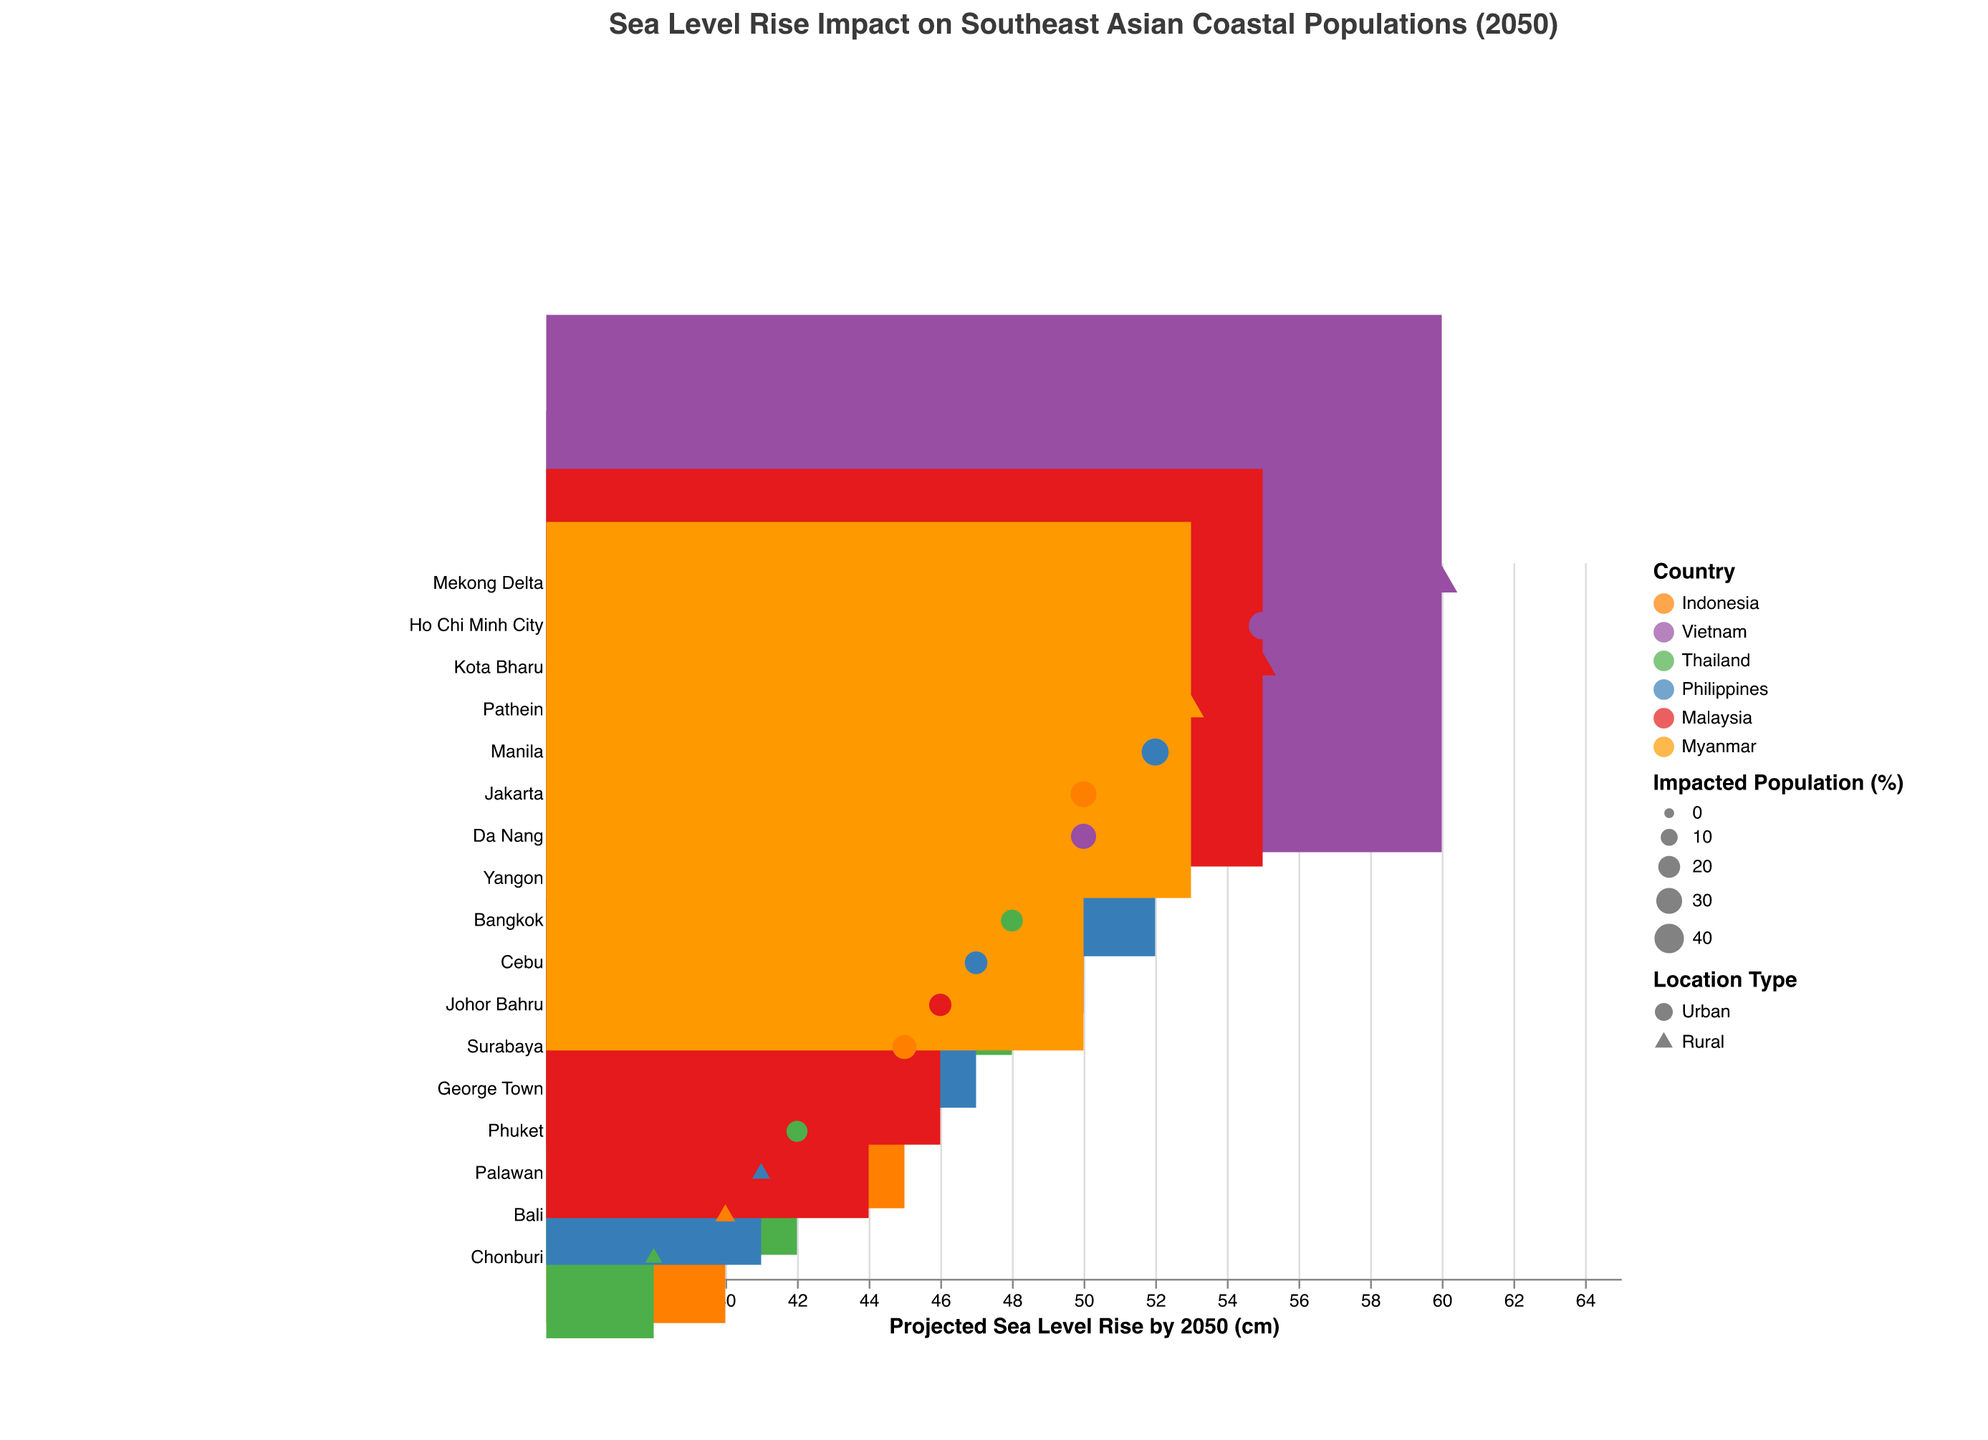What is the projected sea level rise in Jakarta by 2050? The dot for Jakarta aligns with the value 50 cm on the x-axis.
Answer: 50 cm Which location has the highest impacted population percentage and what is the value? The triangle marker representing the rural category in Mekong Delta has the largest size indicating 45% impacting population.
Answer: Mekong Delta, 45% Compare the sea level rise projections for urban locations in Indonesia. Which city is estimated to have the highest rise and what is the value? The urban areas in Indonesia are Jakarta (50 cm), Surabaya (45 cm). Among these, Jakarta has the highest value.
Answer: Jakarta, 50 cm How many urban locations in Southeast Asia are projected to experience a sea level rise of 50 cm or more by 2050? Urban locations meeting the criteria: Jakarta (50 cm), Ho Chi Minh City (55 cm), Da Nang (50 cm), Manila (52 cm), Yangon (50 cm). There are 5 such locations.
Answer: 5 Which country has the largest size marker in the urban category, indicating the highest impacted population percentage, and what is the percentage? Ho Chi Minh City in Vietnam has the largest size marker in urban category, showing 35% impacted population.
Answer: Vietnam, 35% What is the average projected sea level rise for urban areas across all countries? Urban areas' values: Jakarta (50), Surabaya (45), Ho Chi Minh City (55), Da Nang (50), Bangkok (48), Phuket (42), Manila (52), Cebu (47), George Town (44), Johor Bahru (46), Yangon (50). Sum is 529, and there are 11 locations. Average = 529/11 = 48.09 cm.
Answer: 48.09 cm Which rural location has the smallest expected sea level rise by 2050, and what is the rise? Chonburi in Thailand shows the smallest rise at 38 cm.
Answer: Chonburi, 38 cm How does the projected sea level rise in Jakarta compare to that in Ho Chi Minh City? Jakarta's projected rise is 50 cm, whereas Ho Chi Minh City's is 55 cm. Ho Chi Minh City has a higher projected rise.
Answer: Higher in Ho Chi Minh City Calculate the difference in impacted population percentages between rural areas in the Philippines (Palawan) and Malaysia (Kota Bharu). Impacted percentages for Palawan and Kota Bharu are 12% and 32% respectively. Difference = 32 - 12 = 20%.
Answer: 20% Which country has locations with both urban and rural areas above the 50 cm sea level rise mark? Both urban (Ho Chi Minh City, 55 cm; Da Nang, 50 cm) and rural (Mekong Delta, 60 cm) locations in Vietnam exceed 50 cm.
Answer: Vietnam 